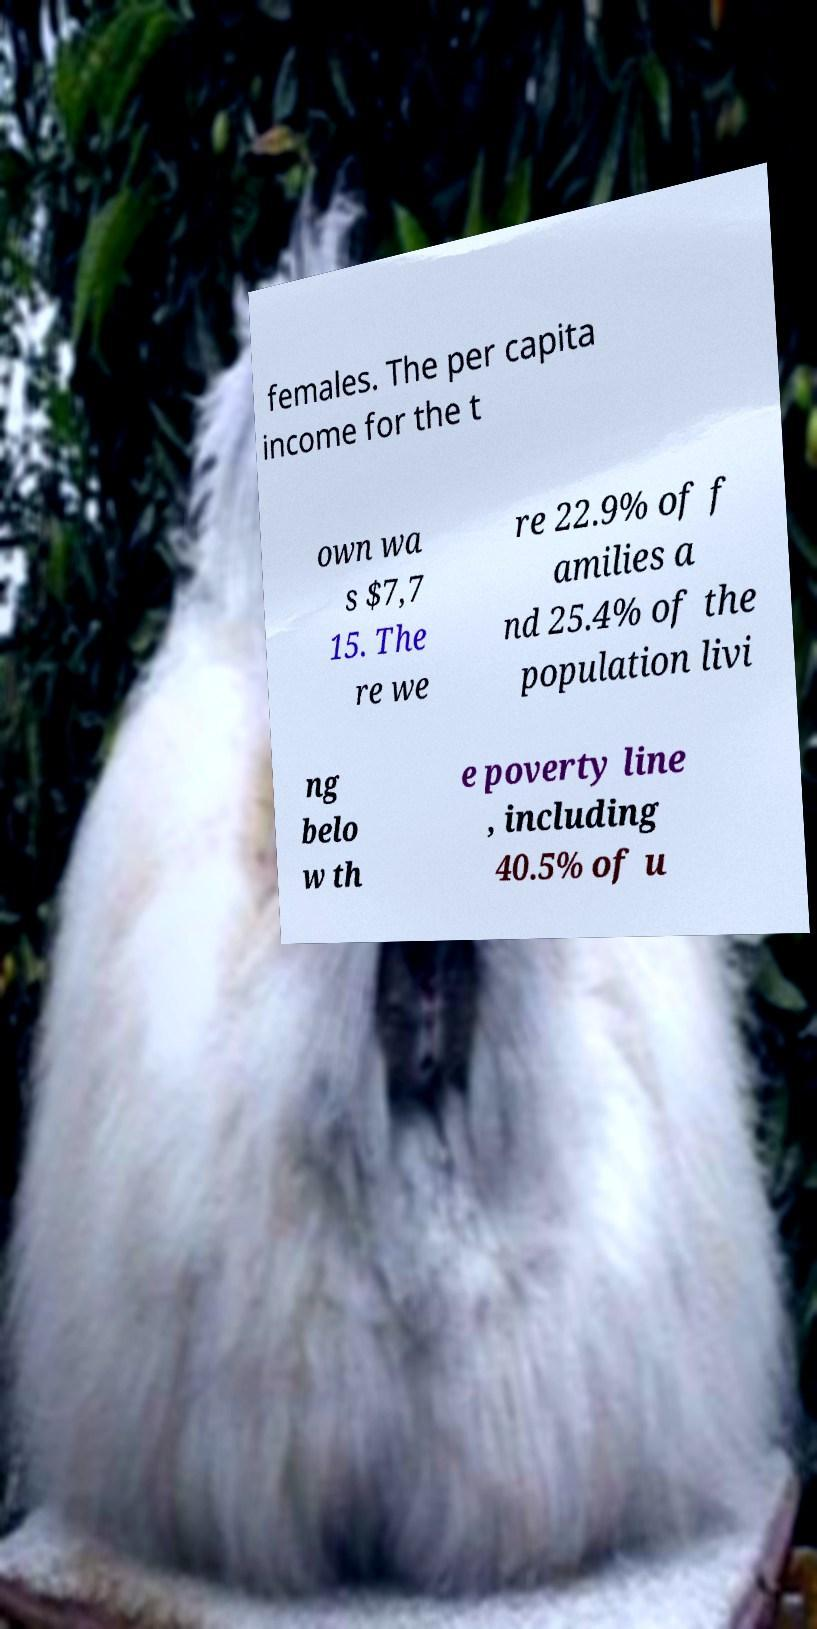Could you assist in decoding the text presented in this image and type it out clearly? females. The per capita income for the t own wa s $7,7 15. The re we re 22.9% of f amilies a nd 25.4% of the population livi ng belo w th e poverty line , including 40.5% of u 